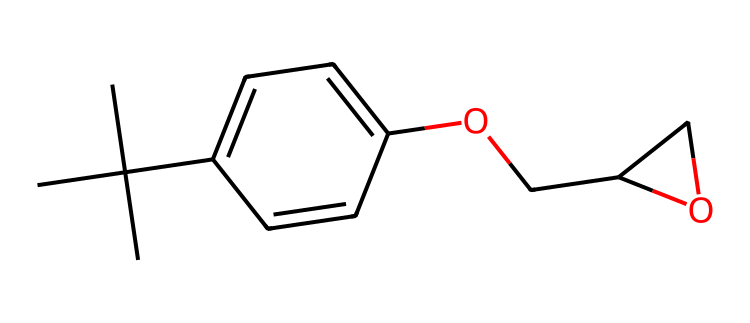What is the total number of carbon atoms in this chemical? Count the carbon (C) atoms in the chemical structure depicted by the SMILES notation. There are nine carbon atoms present in the structure.
Answer: nine How many oxygen atoms are present in the chemical? Inspect the structure for oxygen (O) atoms indicated in the SMILES. There are two oxygen atoms identified in the chemical.
Answer: two What is the degree of unsaturation in this compound? Calculate the degree of unsaturation using the formula (2C + 2 + N - H - X)/2. Here, C=9, H=12, N=0, X=0 results in 3, indicating three rings or double bonds in the structure.
Answer: three What functional group is present in this chemical? Analyze the SMILES, particularly focusing on the hydroxyl group (-OH) seen as part of the ethyl chain in the structure, which indicates the presence of an alcohol functional group.
Answer: alcohol How does the presence of the ether group influence the properties of this resin? The presence of the ether group (as seen in the OCH2 part of the structure) enhances the flexibility and durability of the resin compared to simpler adhesives, making it particularly advantageous in construction applications.
Answer: enhances flexibility What type of compound is represented by this SMILES notation? Understanding the structure and its components, this chemical is categorized as an epoxy resin due to the epoxide functional group typically used in adhesives and coatings.
Answer: epoxy resin Is this chemical likely to be hydrophobic or hydrophilic? Given the presence of hydrocarbon chains and the lack of highly polar functional groups, the structure indicates that the compound is predominantly hydrophobic, likely to repel water.
Answer: hydrophobic 